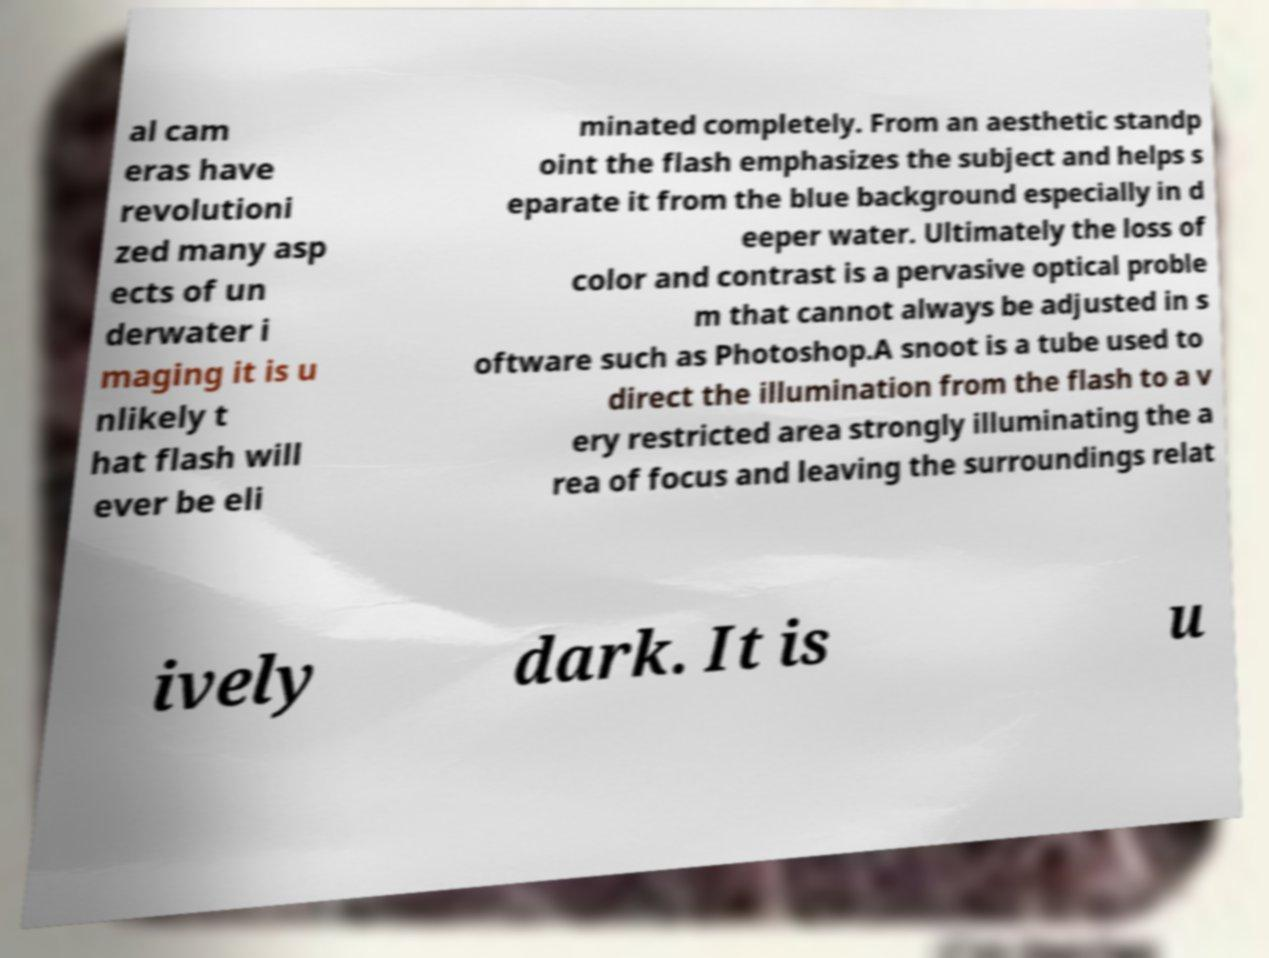Please identify and transcribe the text found in this image. al cam eras have revolutioni zed many asp ects of un derwater i maging it is u nlikely t hat flash will ever be eli minated completely. From an aesthetic standp oint the flash emphasizes the subject and helps s eparate it from the blue background especially in d eeper water. Ultimately the loss of color and contrast is a pervasive optical proble m that cannot always be adjusted in s oftware such as Photoshop.A snoot is a tube used to direct the illumination from the flash to a v ery restricted area strongly illuminating the a rea of focus and leaving the surroundings relat ively dark. It is u 